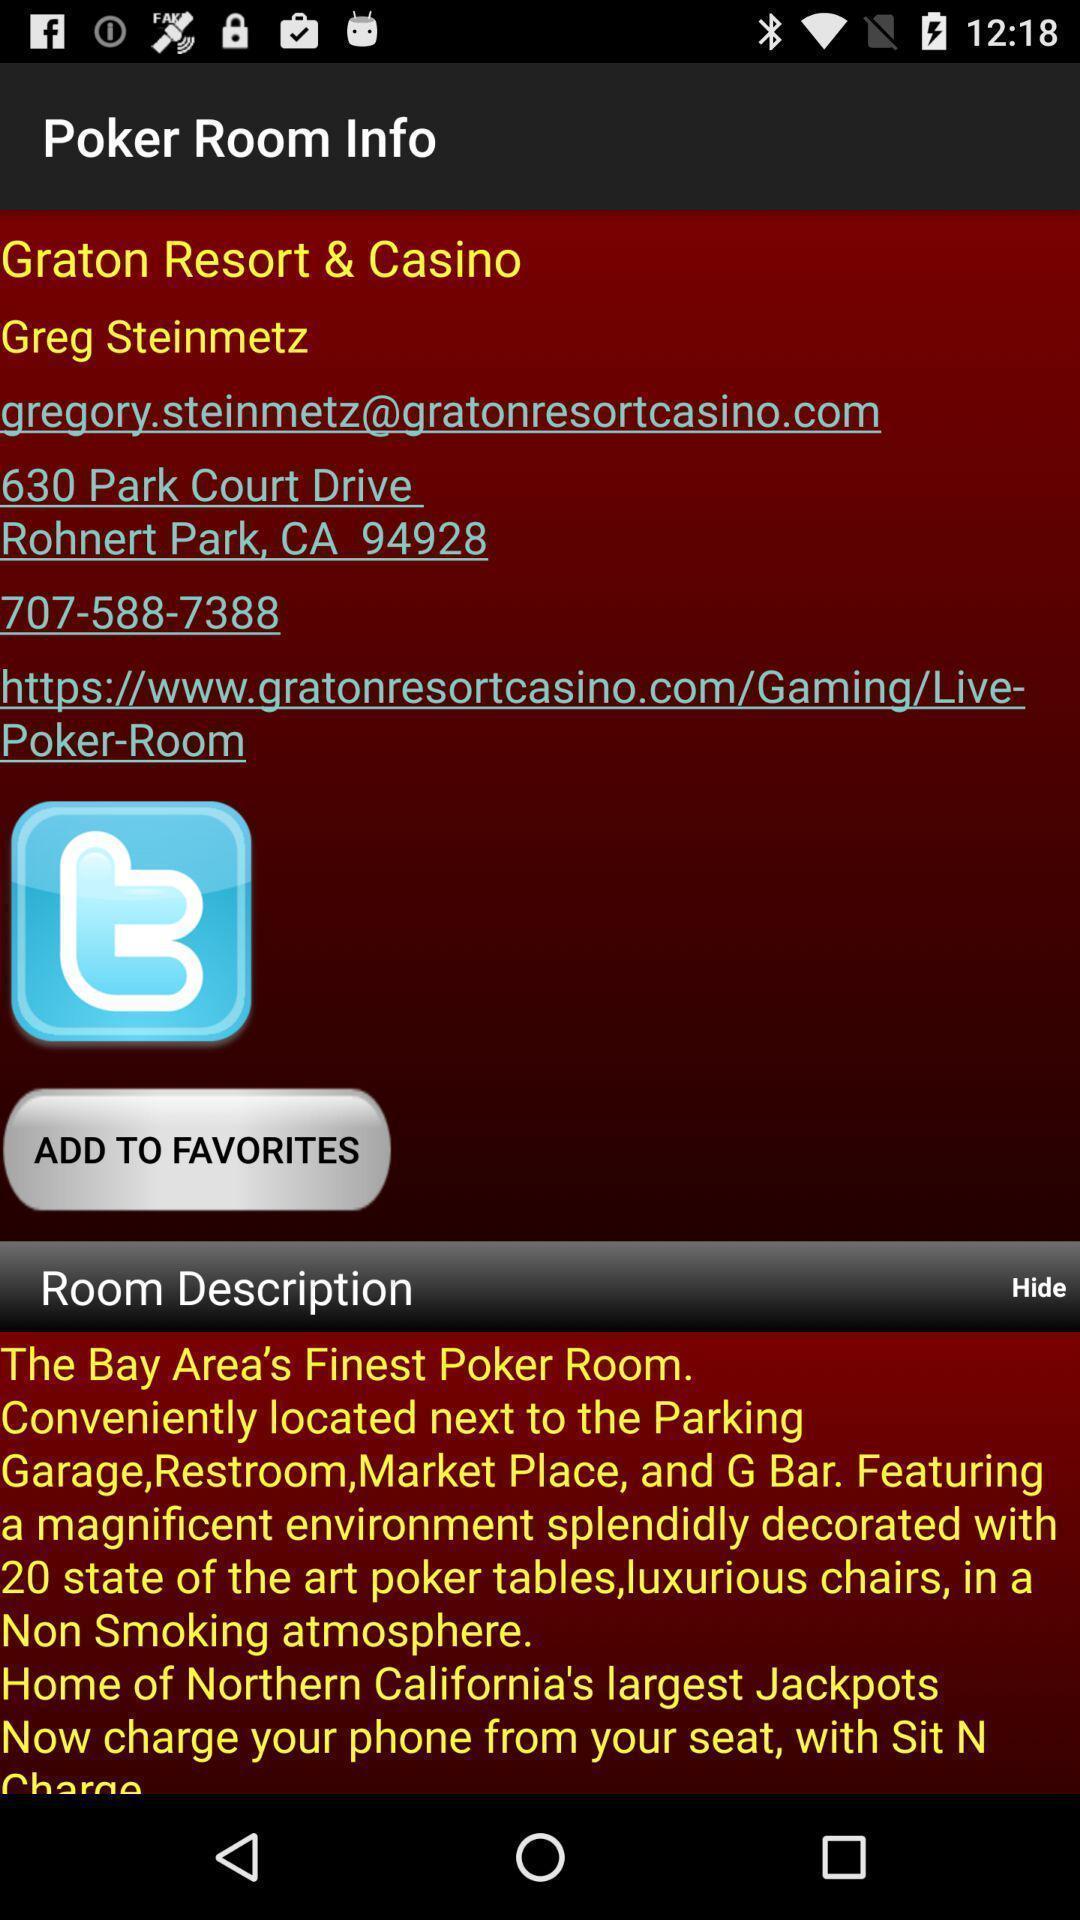Describe the content in this image. Page shows information about an application. 